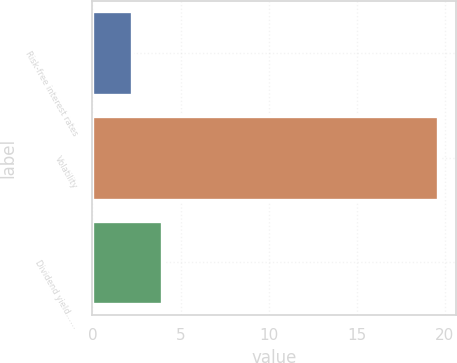<chart> <loc_0><loc_0><loc_500><loc_500><bar_chart><fcel>Risk-free interest rates<fcel>Volatility<fcel>Dividend yield……<nl><fcel>2.23<fcel>19.63<fcel>3.97<nl></chart> 